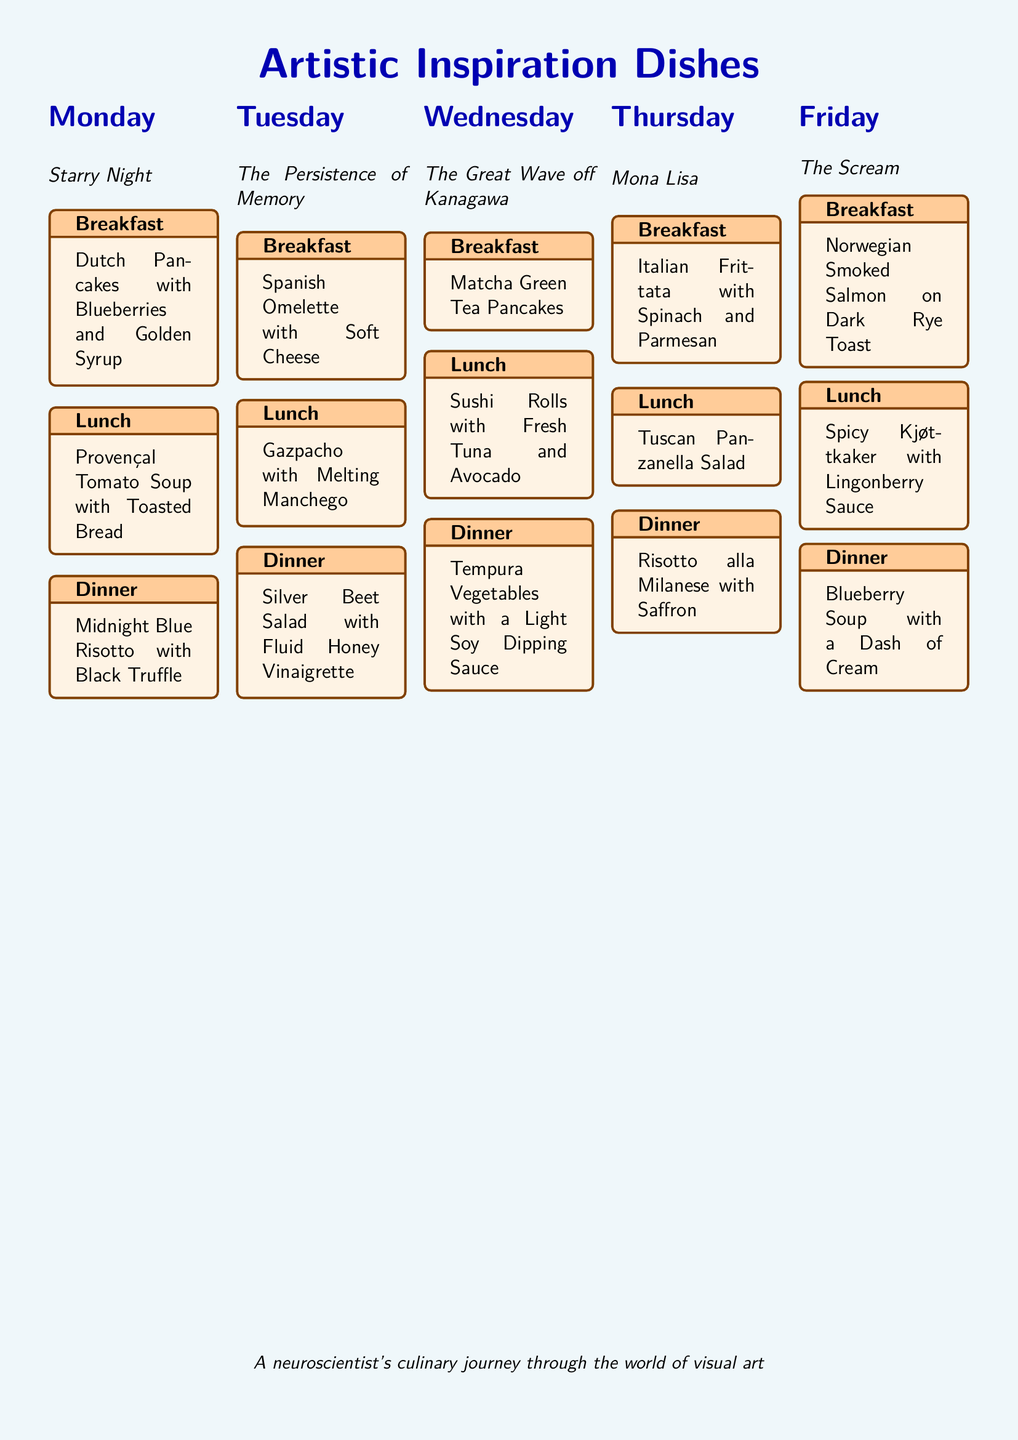What is the first painting featured in the meal plan? The first painting listed is "Starry Night" on Monday.
Answer: Starry Night What type of soup is served for lunch on Tuesday? The lunch on Tuesday features Gazpacho.
Answer: Gazpacho What ingredient is used in the breakfast for Wednesday? The breakfast on Wednesday includes Matcha Green Tea in the pancakes.
Answer: Matcha Green Tea Which day's dinner includes saffron? The dinner on Thursday features Risotto alla Milanese with saffron.
Answer: Thursday What is the theme of the meal plan? The meal plan is inspired by various famous visual artworks.
Answer: Artistic Inspiration Dishes How many different meals are served for dinner throughout the week? There are five different dinners, one for each day from Monday to Friday.
Answer: Five What dish is served on Friday for breakfast? The breakfast on Friday is Norwegian Smoked Salmon on Dark Rye Toast.
Answer: Norwegian Smoked Salmon on Dark Rye Toast Which day features a vegetable salad with a fluid honey vinaigrette? This dish is served on Tuesday, specifically for dinner.
Answer: Tuesday What color theme is the document primarily associated with? The document has a light blue background color theme.
Answer: Light blue 